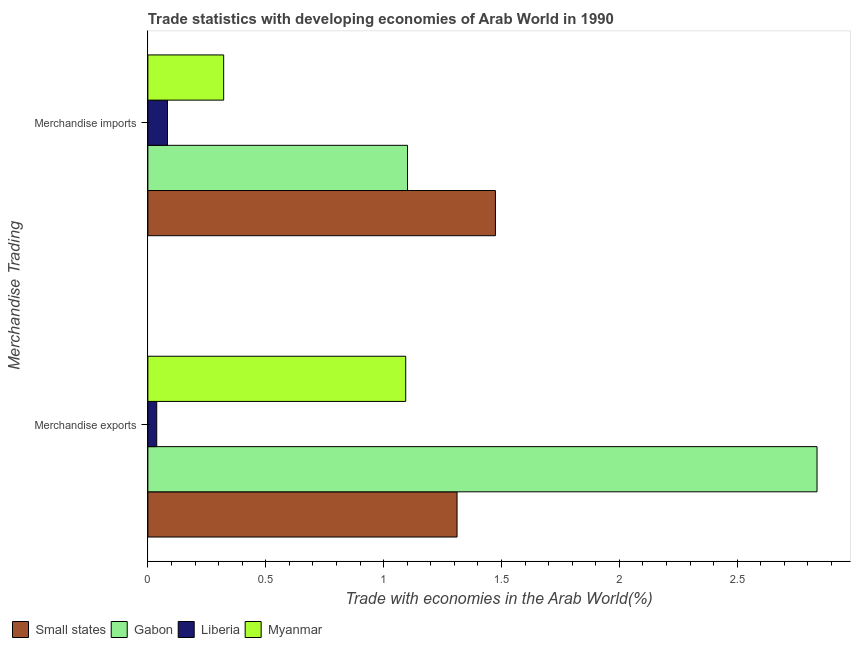Are the number of bars on each tick of the Y-axis equal?
Ensure brevity in your answer.  Yes. How many bars are there on the 2nd tick from the bottom?
Offer a very short reply. 4. What is the label of the 1st group of bars from the top?
Ensure brevity in your answer.  Merchandise imports. What is the merchandise imports in Gabon?
Give a very brief answer. 1.1. Across all countries, what is the maximum merchandise exports?
Keep it short and to the point. 2.84. Across all countries, what is the minimum merchandise imports?
Provide a succinct answer. 0.08. In which country was the merchandise exports maximum?
Give a very brief answer. Gabon. In which country was the merchandise exports minimum?
Provide a short and direct response. Liberia. What is the total merchandise imports in the graph?
Keep it short and to the point. 2.98. What is the difference between the merchandise exports in Gabon and that in Small states?
Give a very brief answer. 1.53. What is the difference between the merchandise imports in Liberia and the merchandise exports in Small states?
Provide a short and direct response. -1.23. What is the average merchandise exports per country?
Offer a terse response. 1.32. What is the difference between the merchandise exports and merchandise imports in Small states?
Offer a very short reply. -0.16. What is the ratio of the merchandise imports in Liberia to that in Myanmar?
Provide a short and direct response. 0.26. What does the 3rd bar from the top in Merchandise imports represents?
Offer a terse response. Gabon. What does the 2nd bar from the bottom in Merchandise imports represents?
Offer a very short reply. Gabon. What is the title of the graph?
Keep it short and to the point. Trade statistics with developing economies of Arab World in 1990. Does "Greece" appear as one of the legend labels in the graph?
Your answer should be very brief. No. What is the label or title of the X-axis?
Offer a terse response. Trade with economies in the Arab World(%). What is the label or title of the Y-axis?
Give a very brief answer. Merchandise Trading. What is the Trade with economies in the Arab World(%) of Small states in Merchandise exports?
Ensure brevity in your answer.  1.31. What is the Trade with economies in the Arab World(%) in Gabon in Merchandise exports?
Your answer should be compact. 2.84. What is the Trade with economies in the Arab World(%) of Liberia in Merchandise exports?
Your answer should be compact. 0.04. What is the Trade with economies in the Arab World(%) in Myanmar in Merchandise exports?
Your answer should be very brief. 1.09. What is the Trade with economies in the Arab World(%) of Small states in Merchandise imports?
Offer a very short reply. 1.47. What is the Trade with economies in the Arab World(%) of Gabon in Merchandise imports?
Provide a succinct answer. 1.1. What is the Trade with economies in the Arab World(%) in Liberia in Merchandise imports?
Offer a very short reply. 0.08. What is the Trade with economies in the Arab World(%) in Myanmar in Merchandise imports?
Offer a terse response. 0.32. Across all Merchandise Trading, what is the maximum Trade with economies in the Arab World(%) of Small states?
Provide a short and direct response. 1.47. Across all Merchandise Trading, what is the maximum Trade with economies in the Arab World(%) in Gabon?
Keep it short and to the point. 2.84. Across all Merchandise Trading, what is the maximum Trade with economies in the Arab World(%) of Liberia?
Offer a terse response. 0.08. Across all Merchandise Trading, what is the maximum Trade with economies in the Arab World(%) in Myanmar?
Give a very brief answer. 1.09. Across all Merchandise Trading, what is the minimum Trade with economies in the Arab World(%) of Small states?
Your answer should be very brief. 1.31. Across all Merchandise Trading, what is the minimum Trade with economies in the Arab World(%) in Gabon?
Your answer should be compact. 1.1. Across all Merchandise Trading, what is the minimum Trade with economies in the Arab World(%) in Liberia?
Offer a terse response. 0.04. Across all Merchandise Trading, what is the minimum Trade with economies in the Arab World(%) in Myanmar?
Your response must be concise. 0.32. What is the total Trade with economies in the Arab World(%) in Small states in the graph?
Provide a succinct answer. 2.79. What is the total Trade with economies in the Arab World(%) in Gabon in the graph?
Your answer should be compact. 3.94. What is the total Trade with economies in the Arab World(%) of Liberia in the graph?
Offer a very short reply. 0.12. What is the total Trade with economies in the Arab World(%) of Myanmar in the graph?
Your response must be concise. 1.42. What is the difference between the Trade with economies in the Arab World(%) in Small states in Merchandise exports and that in Merchandise imports?
Your answer should be very brief. -0.16. What is the difference between the Trade with economies in the Arab World(%) of Gabon in Merchandise exports and that in Merchandise imports?
Make the answer very short. 1.74. What is the difference between the Trade with economies in the Arab World(%) in Liberia in Merchandise exports and that in Merchandise imports?
Keep it short and to the point. -0.05. What is the difference between the Trade with economies in the Arab World(%) of Myanmar in Merchandise exports and that in Merchandise imports?
Make the answer very short. 0.77. What is the difference between the Trade with economies in the Arab World(%) of Small states in Merchandise exports and the Trade with economies in the Arab World(%) of Gabon in Merchandise imports?
Offer a very short reply. 0.21. What is the difference between the Trade with economies in the Arab World(%) in Small states in Merchandise exports and the Trade with economies in the Arab World(%) in Liberia in Merchandise imports?
Offer a terse response. 1.23. What is the difference between the Trade with economies in the Arab World(%) in Gabon in Merchandise exports and the Trade with economies in the Arab World(%) in Liberia in Merchandise imports?
Keep it short and to the point. 2.76. What is the difference between the Trade with economies in the Arab World(%) in Gabon in Merchandise exports and the Trade with economies in the Arab World(%) in Myanmar in Merchandise imports?
Your answer should be very brief. 2.52. What is the difference between the Trade with economies in the Arab World(%) of Liberia in Merchandise exports and the Trade with economies in the Arab World(%) of Myanmar in Merchandise imports?
Your answer should be very brief. -0.28. What is the average Trade with economies in the Arab World(%) of Small states per Merchandise Trading?
Provide a succinct answer. 1.39. What is the average Trade with economies in the Arab World(%) in Gabon per Merchandise Trading?
Keep it short and to the point. 1.97. What is the average Trade with economies in the Arab World(%) of Liberia per Merchandise Trading?
Offer a terse response. 0.06. What is the average Trade with economies in the Arab World(%) of Myanmar per Merchandise Trading?
Offer a very short reply. 0.71. What is the difference between the Trade with economies in the Arab World(%) of Small states and Trade with economies in the Arab World(%) of Gabon in Merchandise exports?
Keep it short and to the point. -1.53. What is the difference between the Trade with economies in the Arab World(%) in Small states and Trade with economies in the Arab World(%) in Liberia in Merchandise exports?
Provide a short and direct response. 1.27. What is the difference between the Trade with economies in the Arab World(%) in Small states and Trade with economies in the Arab World(%) in Myanmar in Merchandise exports?
Offer a terse response. 0.22. What is the difference between the Trade with economies in the Arab World(%) of Gabon and Trade with economies in the Arab World(%) of Liberia in Merchandise exports?
Provide a short and direct response. 2.8. What is the difference between the Trade with economies in the Arab World(%) in Gabon and Trade with economies in the Arab World(%) in Myanmar in Merchandise exports?
Keep it short and to the point. 1.74. What is the difference between the Trade with economies in the Arab World(%) in Liberia and Trade with economies in the Arab World(%) in Myanmar in Merchandise exports?
Offer a very short reply. -1.06. What is the difference between the Trade with economies in the Arab World(%) in Small states and Trade with economies in the Arab World(%) in Gabon in Merchandise imports?
Ensure brevity in your answer.  0.37. What is the difference between the Trade with economies in the Arab World(%) in Small states and Trade with economies in the Arab World(%) in Liberia in Merchandise imports?
Your answer should be compact. 1.39. What is the difference between the Trade with economies in the Arab World(%) in Small states and Trade with economies in the Arab World(%) in Myanmar in Merchandise imports?
Offer a very short reply. 1.15. What is the difference between the Trade with economies in the Arab World(%) in Gabon and Trade with economies in the Arab World(%) in Liberia in Merchandise imports?
Make the answer very short. 1.02. What is the difference between the Trade with economies in the Arab World(%) in Gabon and Trade with economies in the Arab World(%) in Myanmar in Merchandise imports?
Offer a very short reply. 0.78. What is the difference between the Trade with economies in the Arab World(%) in Liberia and Trade with economies in the Arab World(%) in Myanmar in Merchandise imports?
Offer a very short reply. -0.24. What is the ratio of the Trade with economies in the Arab World(%) in Small states in Merchandise exports to that in Merchandise imports?
Give a very brief answer. 0.89. What is the ratio of the Trade with economies in the Arab World(%) of Gabon in Merchandise exports to that in Merchandise imports?
Offer a terse response. 2.58. What is the ratio of the Trade with economies in the Arab World(%) of Liberia in Merchandise exports to that in Merchandise imports?
Your response must be concise. 0.45. What is the ratio of the Trade with economies in the Arab World(%) in Myanmar in Merchandise exports to that in Merchandise imports?
Provide a succinct answer. 3.4. What is the difference between the highest and the second highest Trade with economies in the Arab World(%) in Small states?
Keep it short and to the point. 0.16. What is the difference between the highest and the second highest Trade with economies in the Arab World(%) of Gabon?
Your answer should be very brief. 1.74. What is the difference between the highest and the second highest Trade with economies in the Arab World(%) of Liberia?
Your response must be concise. 0.05. What is the difference between the highest and the second highest Trade with economies in the Arab World(%) of Myanmar?
Make the answer very short. 0.77. What is the difference between the highest and the lowest Trade with economies in the Arab World(%) in Small states?
Offer a terse response. 0.16. What is the difference between the highest and the lowest Trade with economies in the Arab World(%) of Gabon?
Your answer should be very brief. 1.74. What is the difference between the highest and the lowest Trade with economies in the Arab World(%) of Liberia?
Provide a short and direct response. 0.05. What is the difference between the highest and the lowest Trade with economies in the Arab World(%) of Myanmar?
Your answer should be very brief. 0.77. 